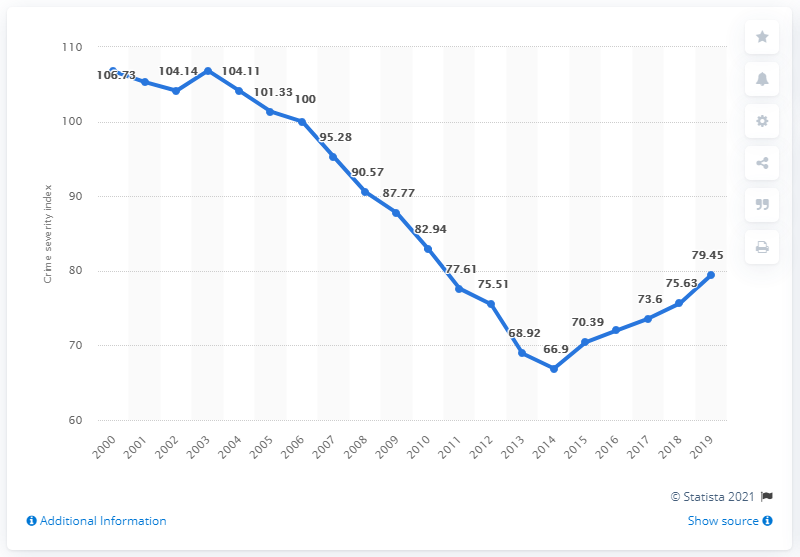Point out several critical features in this image. The sum of the points in the graph that have a value below 70 is 135.82. In 2019, the crime severity index in Canada was 79.45. In 2015, the crime severity index in Canada was 70.39. This index is a measure of the overall seriousness of crime in a given area or jurisdiction. It takes into account the number of incidents of crime as well as the severity of the crimes committed. In 2000, the crime severity index for Canada was 106.73. 